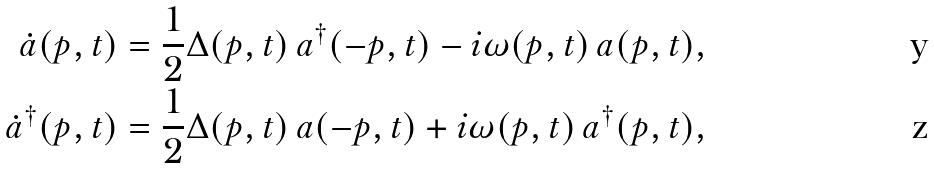Convert formula to latex. <formula><loc_0><loc_0><loc_500><loc_500>\dot { a } ( p , t ) = \frac { 1 } { 2 } \Delta ( p , t ) \, a ^ { \dagger } ( - p , t ) - i \omega ( p , t ) \, a ( p , t ) , \\ \dot { a } ^ { \dagger } ( p , t ) = \frac { 1 } { 2 } \Delta ( p , t ) \, a ( - p , t ) + i \omega ( p , t ) \, a ^ { \dagger } ( p , t ) ,</formula> 